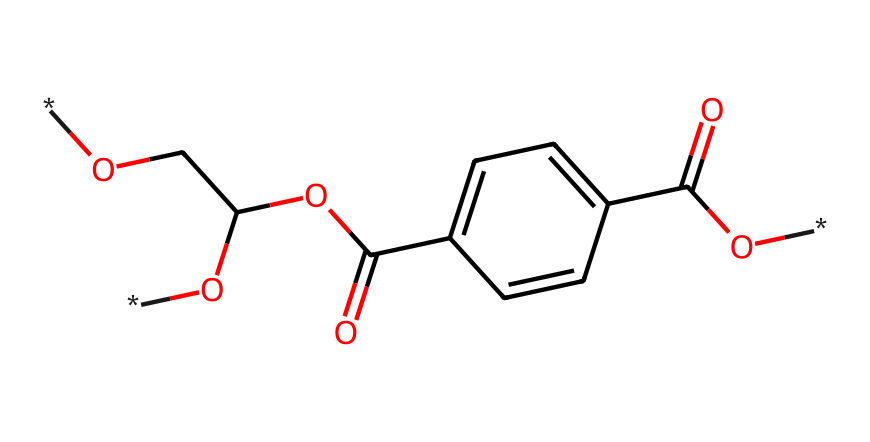What type of polymer is represented by this chemical structure? The structure contains repeating units derived from terephthalic acid and ethylene glycol, typical of condensation polymers produced in step-growth polymerization.
Answer: polyester How many carbon atoms are present in the structure? By counting the carbon atoms in the SMILES representation, I find a total of 10 carbon atoms connected in the structure.
Answer: 10 What functional group indicates that this compound is an ester? The structure contains the -O-C(=O)- part, which is characteristic of an ester linkage, formed between the alcohol (ethylene glycol) and the acid (terephthalic acid).
Answer: ester How many carboxylic acid groups are present in this structure? Evaluating the SMILES reveals one -COOH (carboxylic acid) group attached in the structure, indicating the presence of only one carboxylic acid.
Answer: 1 What is the degree of polymerization in this PET structure? The degree of polymerization can be estimated by identifying the repeating units; this structure suggests a basic repeating unit forming the polymer chain, so it's typically multiple units, but the specific number isn't indicated directly in the SMILES provided.
Answer: variable Is polyethylene terephthalate biodegradable? The structure indicates that it’s a polyester often used for durable products, which are resistant to biodegradation due to their strong covalent bonds and stable backbone.
Answer: no What type of intermolecular forces are likely to be present in PET? The presence of polar carbonyl groups in the ester functionality suggests intermolecular hydrogen bonding between chains, along with Van der Waals forces due to the hydrocarbon portions.
Answer: hydrogen bonds 